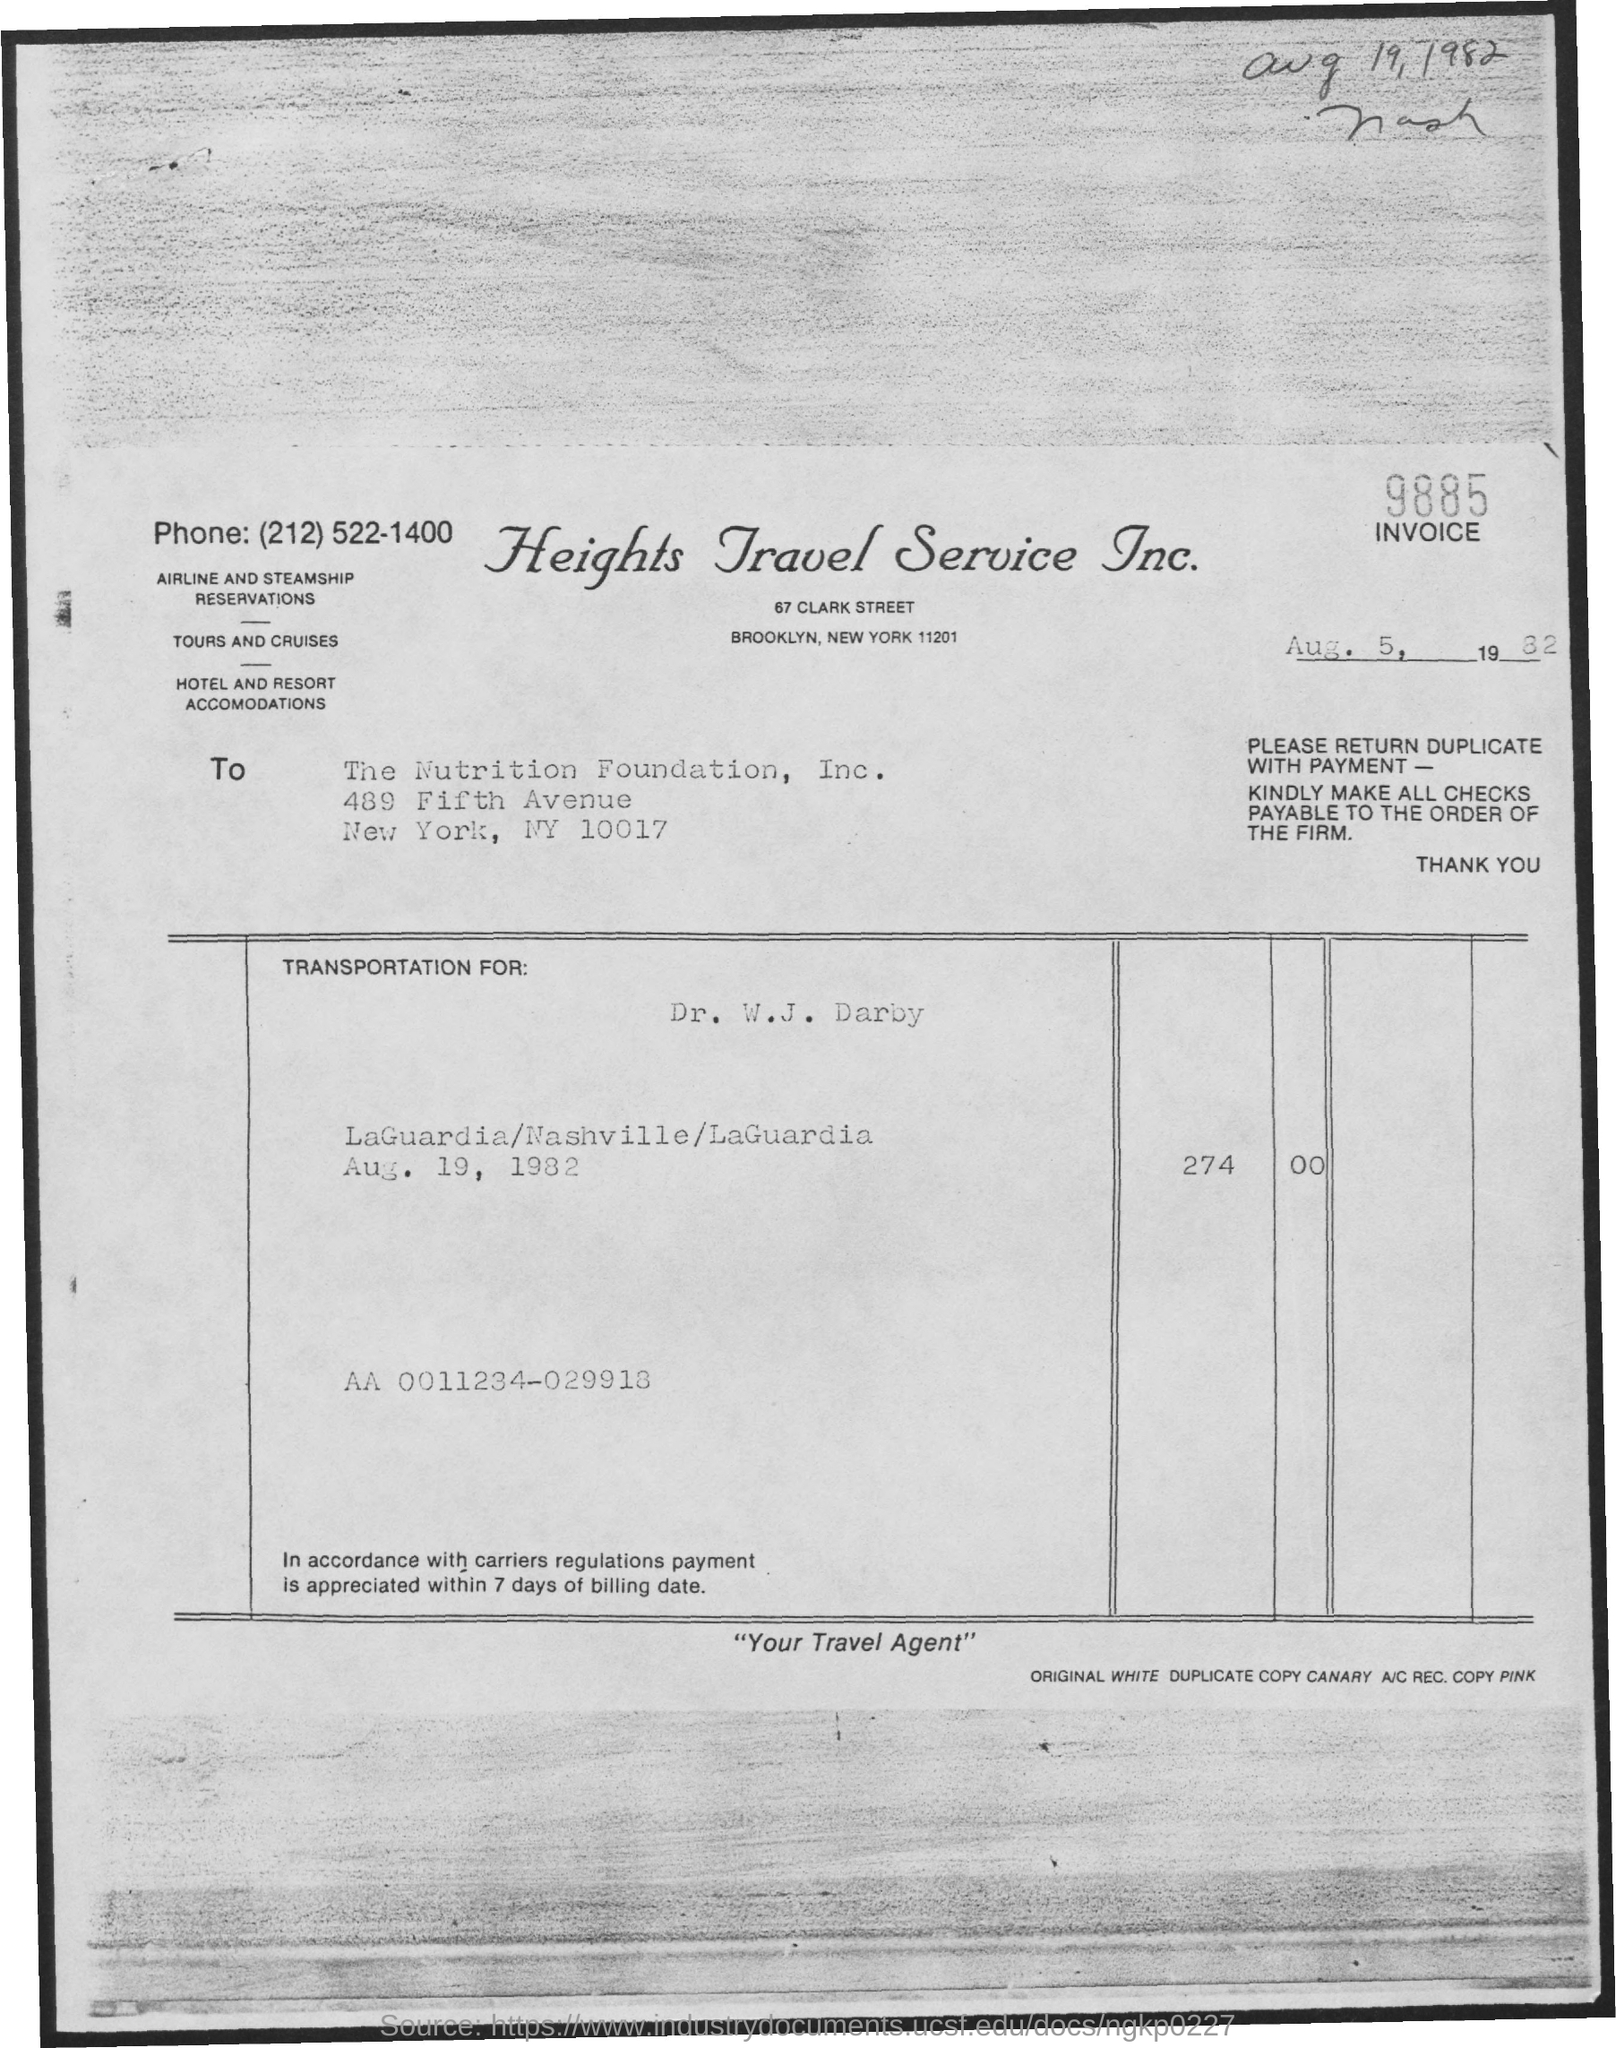Draw attention to some important aspects in this diagram. The invoice's issued date is August 5, 1982. The invoice number provided in the document is 9885. The invoice was issued by Heights Travel Service Inc. The Nutrition Foundation, Inc. issued the invoice in the name of a company. 